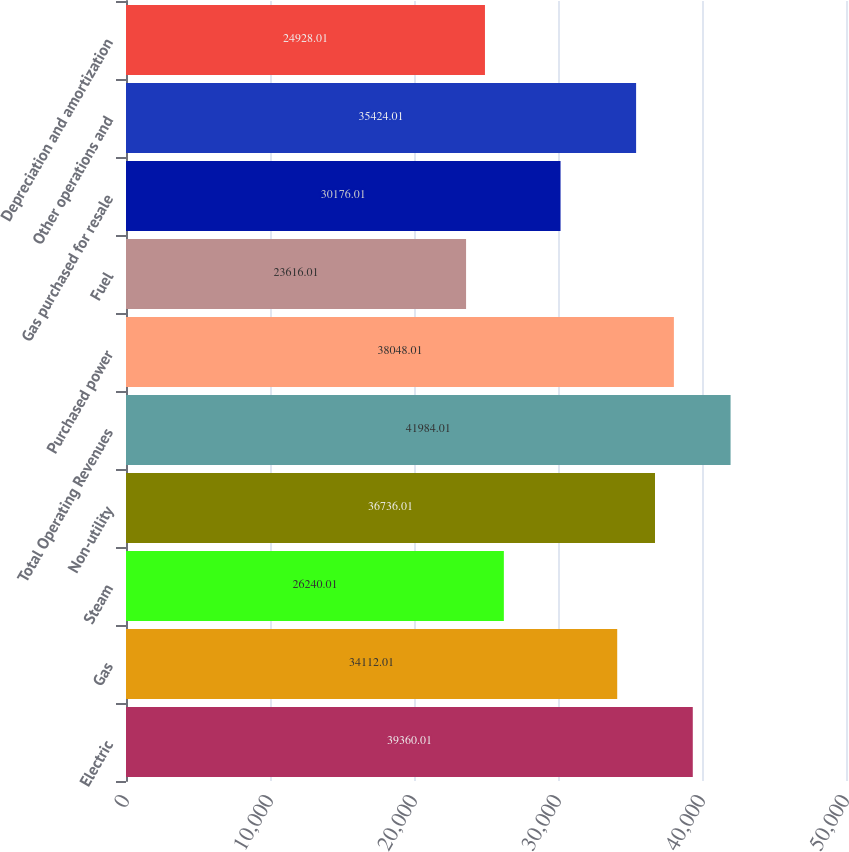<chart> <loc_0><loc_0><loc_500><loc_500><bar_chart><fcel>Electric<fcel>Gas<fcel>Steam<fcel>Non-utility<fcel>Total Operating Revenues<fcel>Purchased power<fcel>Fuel<fcel>Gas purchased for resale<fcel>Other operations and<fcel>Depreciation and amortization<nl><fcel>39360<fcel>34112<fcel>26240<fcel>36736<fcel>41984<fcel>38048<fcel>23616<fcel>30176<fcel>35424<fcel>24928<nl></chart> 